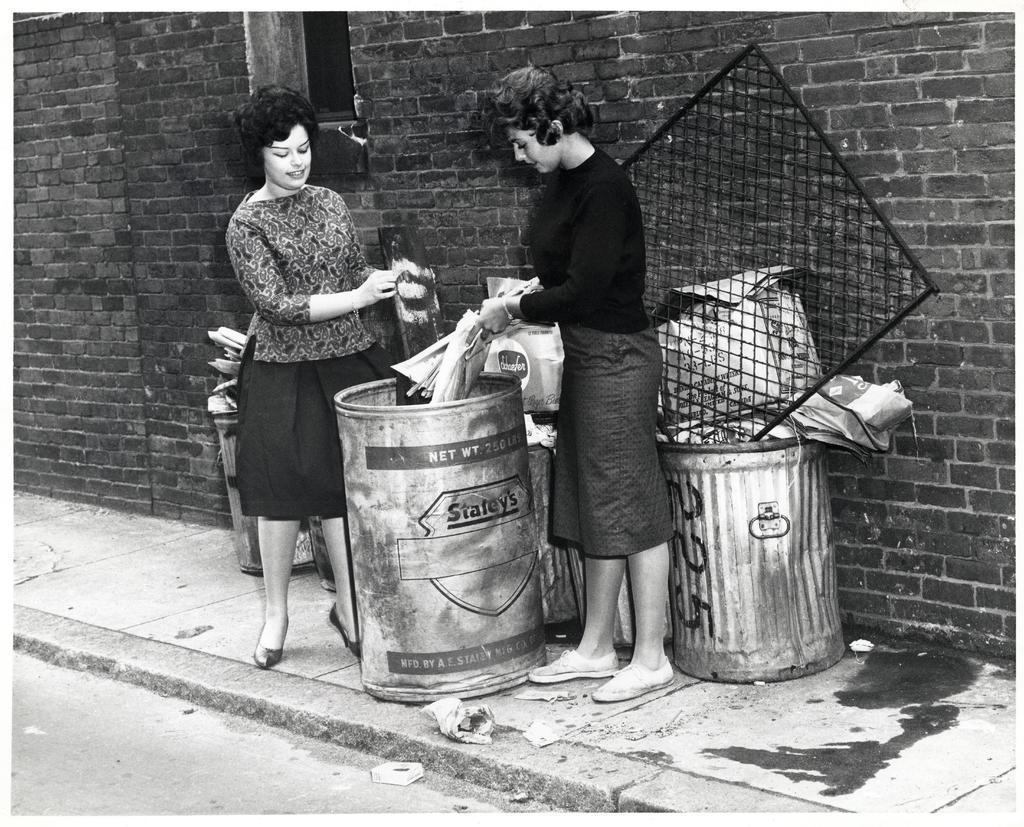<image>
Write a terse but informative summary of the picture. Two women putting trashcan into a Staley's garbage can. 